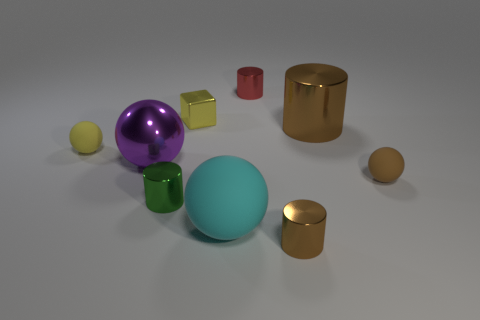How many tiny objects are in front of the big cylinder and behind the purple metal object? In the scene, there is one small yellow cube situated in front of the large golden cylinder and behind the large purple sphere, which could be considered a metal object given its lustrous finish. 